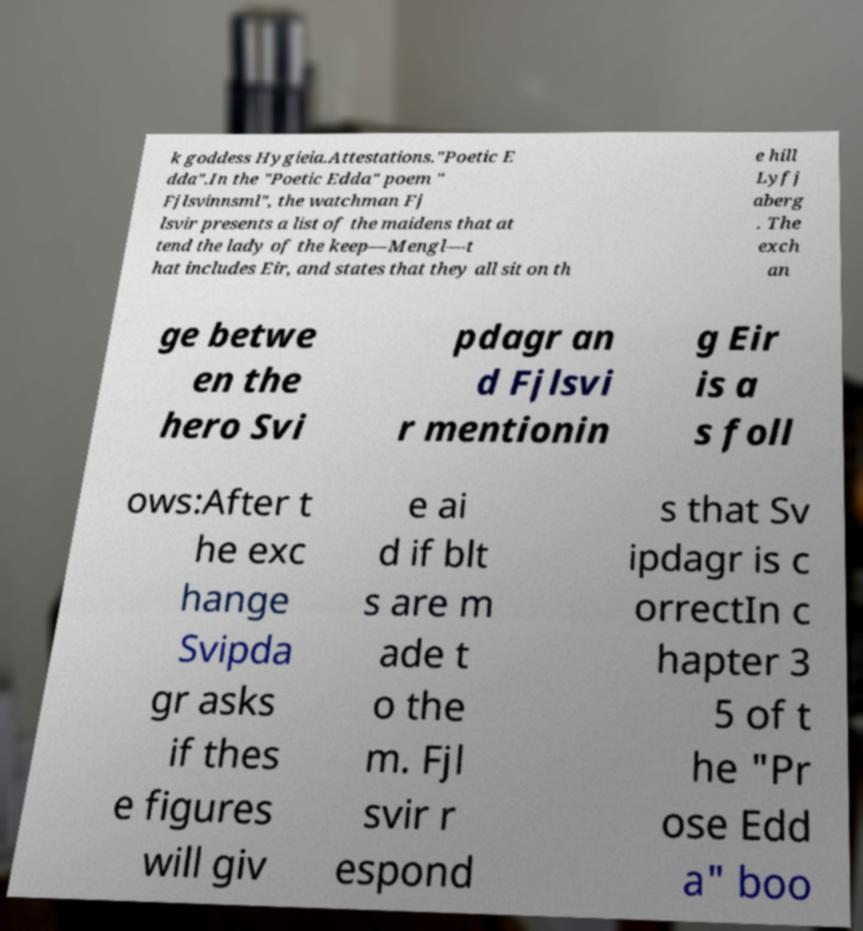Can you accurately transcribe the text from the provided image for me? k goddess Hygieia.Attestations."Poetic E dda".In the "Poetic Edda" poem " Fjlsvinnsml", the watchman Fj lsvir presents a list of the maidens that at tend the lady of the keep—Mengl—t hat includes Eir, and states that they all sit on th e hill Lyfj aberg . The exch an ge betwe en the hero Svi pdagr an d Fjlsvi r mentionin g Eir is a s foll ows:After t he exc hange Svipda gr asks if thes e figures will giv e ai d if blt s are m ade t o the m. Fjl svir r espond s that Sv ipdagr is c orrectIn c hapter 3 5 of t he "Pr ose Edd a" boo 